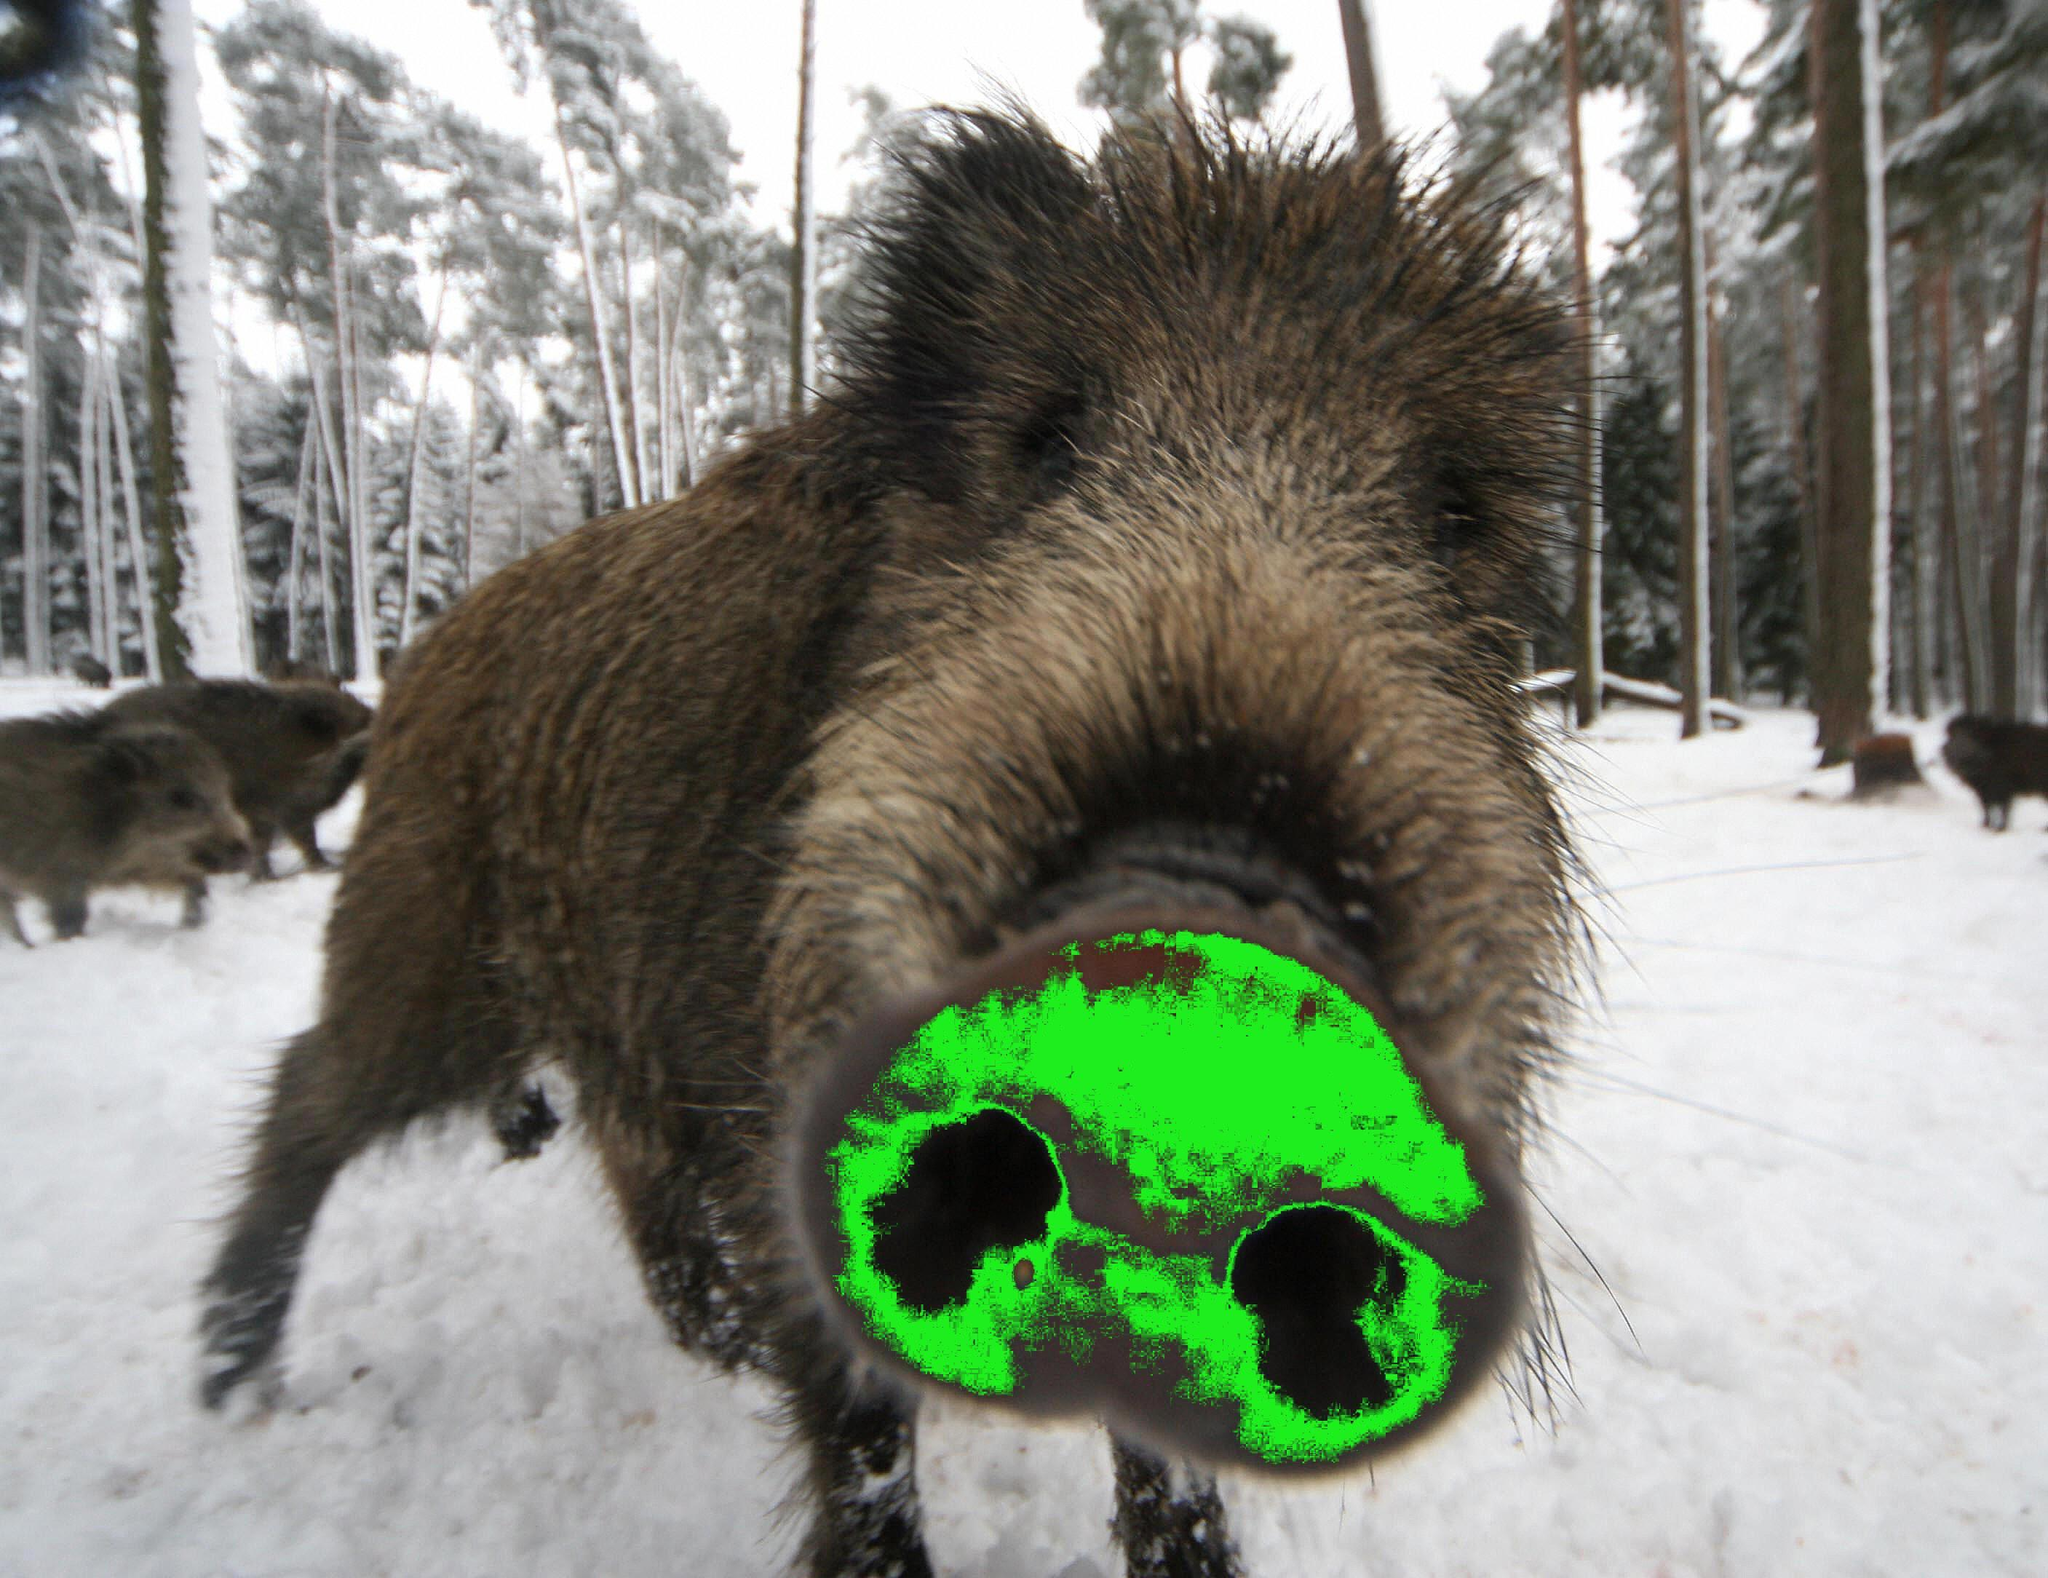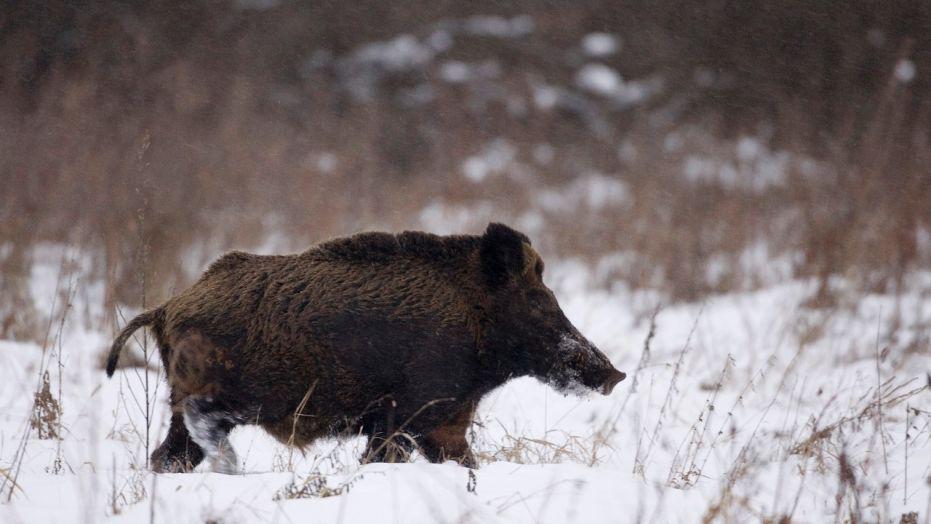The first image is the image on the left, the second image is the image on the right. Evaluate the accuracy of this statement regarding the images: "The combined images contain three pigs, and the right image contains twice as many pigs as the left image.". Is it true? Answer yes or no. No. The first image is the image on the left, the second image is the image on the right. Evaluate the accuracy of this statement regarding the images: "The right image contains exactly two pigs.". Is it true? Answer yes or no. No. 